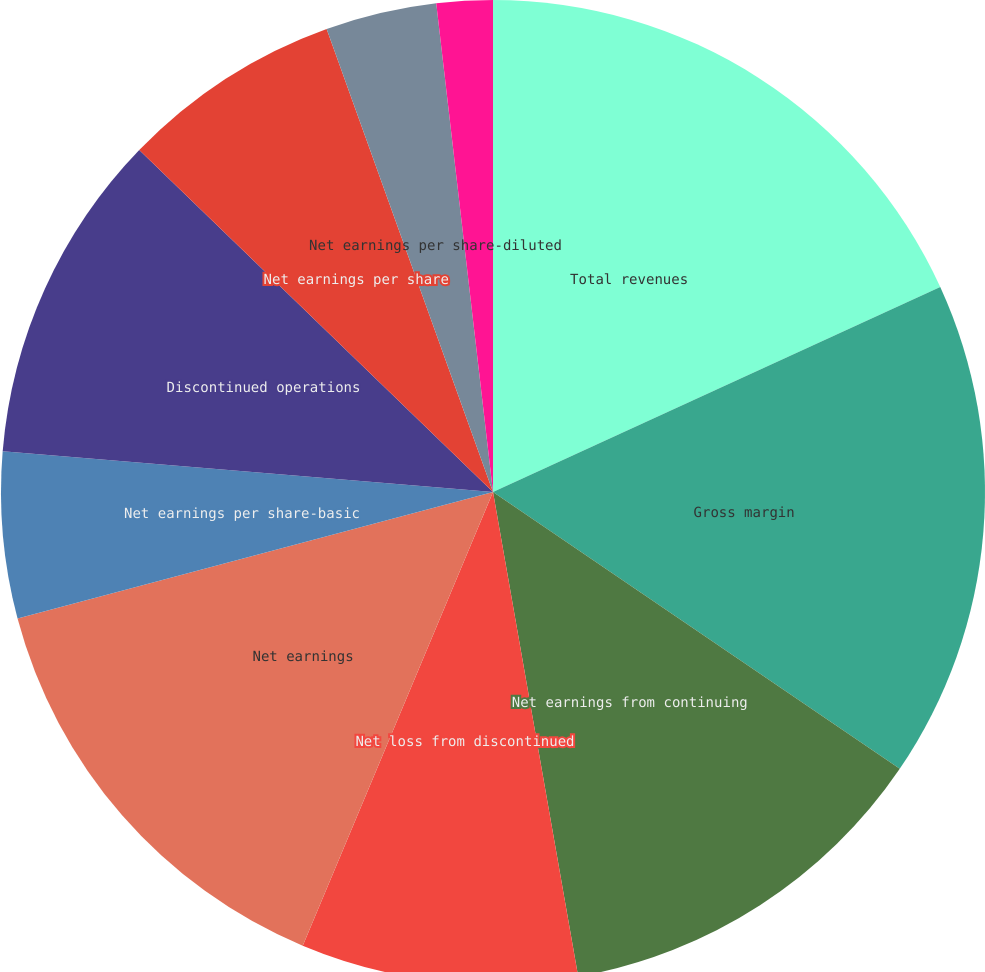Convert chart to OTSL. <chart><loc_0><loc_0><loc_500><loc_500><pie_chart><fcel>Total revenues<fcel>Gross margin<fcel>Net earnings from continuing<fcel>Net loss from discontinued<fcel>Net earnings<fcel>Net earnings per share-basic<fcel>Discontinued operations<fcel>Net earnings per share<fcel>Net earnings per share-diluted<fcel>Net earnings (loss) per<nl><fcel>18.16%<fcel>16.35%<fcel>12.72%<fcel>9.09%<fcel>14.54%<fcel>5.46%<fcel>10.91%<fcel>7.28%<fcel>3.65%<fcel>1.84%<nl></chart> 